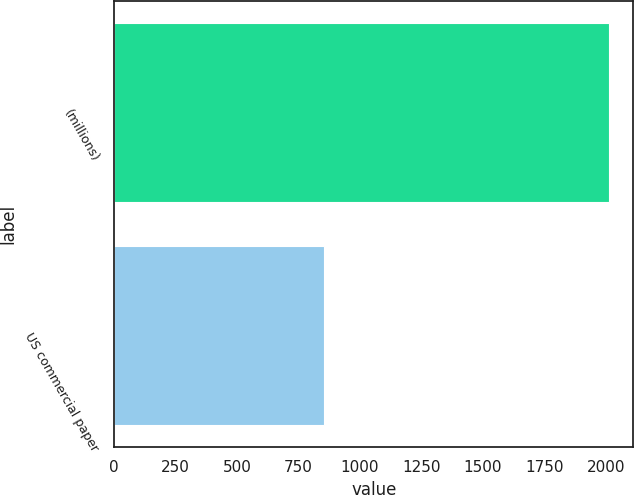Convert chart. <chart><loc_0><loc_0><loc_500><loc_500><bar_chart><fcel>(millions)<fcel>US commercial paper<nl><fcel>2012<fcel>853<nl></chart> 